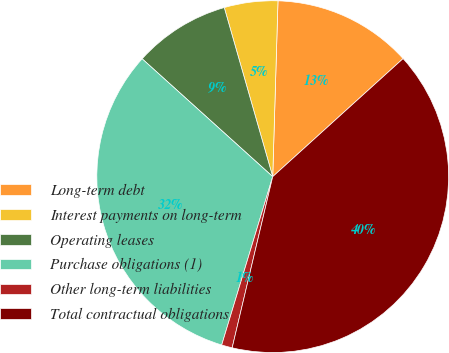<chart> <loc_0><loc_0><loc_500><loc_500><pie_chart><fcel>Long-term debt<fcel>Interest payments on long-term<fcel>Operating leases<fcel>Purchase obligations (1)<fcel>Other long-term liabilities<fcel>Total contractual obligations<nl><fcel>12.81%<fcel>4.92%<fcel>8.87%<fcel>32.0%<fcel>0.98%<fcel>40.41%<nl></chart> 